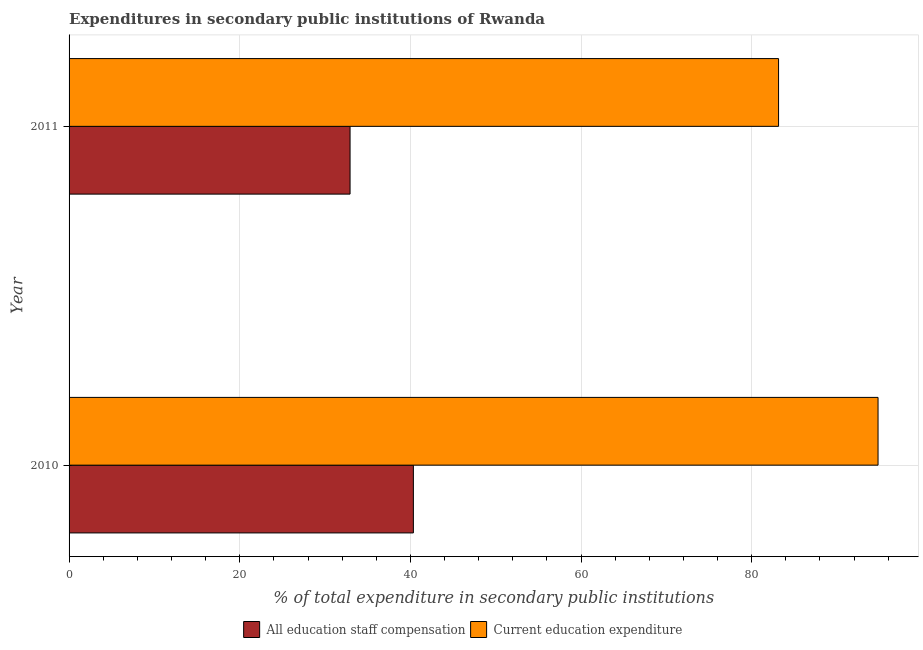How many different coloured bars are there?
Ensure brevity in your answer.  2. Are the number of bars per tick equal to the number of legend labels?
Your response must be concise. Yes. How many bars are there on the 2nd tick from the bottom?
Provide a short and direct response. 2. In how many cases, is the number of bars for a given year not equal to the number of legend labels?
Provide a succinct answer. 0. What is the expenditure in education in 2010?
Your response must be concise. 94.8. Across all years, what is the maximum expenditure in education?
Ensure brevity in your answer.  94.8. Across all years, what is the minimum expenditure in education?
Provide a short and direct response. 83.15. What is the total expenditure in education in the graph?
Keep it short and to the point. 177.95. What is the difference between the expenditure in education in 2010 and that in 2011?
Ensure brevity in your answer.  11.66. What is the difference between the expenditure in education in 2011 and the expenditure in staff compensation in 2010?
Your answer should be compact. 42.8. What is the average expenditure in education per year?
Offer a very short reply. 88.97. In the year 2011, what is the difference between the expenditure in staff compensation and expenditure in education?
Your answer should be very brief. -50.22. What is the ratio of the expenditure in education in 2010 to that in 2011?
Provide a succinct answer. 1.14. Is the difference between the expenditure in education in 2010 and 2011 greater than the difference between the expenditure in staff compensation in 2010 and 2011?
Make the answer very short. Yes. In how many years, is the expenditure in staff compensation greater than the average expenditure in staff compensation taken over all years?
Ensure brevity in your answer.  1. What does the 1st bar from the top in 2011 represents?
Ensure brevity in your answer.  Current education expenditure. What does the 1st bar from the bottom in 2011 represents?
Provide a short and direct response. All education staff compensation. Are all the bars in the graph horizontal?
Keep it short and to the point. Yes. Are the values on the major ticks of X-axis written in scientific E-notation?
Your response must be concise. No. Does the graph contain grids?
Your response must be concise. Yes. How many legend labels are there?
Your response must be concise. 2. How are the legend labels stacked?
Make the answer very short. Horizontal. What is the title of the graph?
Your response must be concise. Expenditures in secondary public institutions of Rwanda. Does "Gasoline" appear as one of the legend labels in the graph?
Provide a succinct answer. No. What is the label or title of the X-axis?
Give a very brief answer. % of total expenditure in secondary public institutions. What is the label or title of the Y-axis?
Your answer should be very brief. Year. What is the % of total expenditure in secondary public institutions in All education staff compensation in 2010?
Provide a short and direct response. 40.35. What is the % of total expenditure in secondary public institutions in Current education expenditure in 2010?
Your response must be concise. 94.8. What is the % of total expenditure in secondary public institutions in All education staff compensation in 2011?
Offer a terse response. 32.93. What is the % of total expenditure in secondary public institutions in Current education expenditure in 2011?
Your answer should be very brief. 83.15. Across all years, what is the maximum % of total expenditure in secondary public institutions of All education staff compensation?
Give a very brief answer. 40.35. Across all years, what is the maximum % of total expenditure in secondary public institutions of Current education expenditure?
Give a very brief answer. 94.8. Across all years, what is the minimum % of total expenditure in secondary public institutions of All education staff compensation?
Offer a terse response. 32.93. Across all years, what is the minimum % of total expenditure in secondary public institutions of Current education expenditure?
Your answer should be compact. 83.15. What is the total % of total expenditure in secondary public institutions of All education staff compensation in the graph?
Your response must be concise. 73.28. What is the total % of total expenditure in secondary public institutions of Current education expenditure in the graph?
Offer a terse response. 177.95. What is the difference between the % of total expenditure in secondary public institutions of All education staff compensation in 2010 and that in 2011?
Provide a short and direct response. 7.42. What is the difference between the % of total expenditure in secondary public institutions of Current education expenditure in 2010 and that in 2011?
Offer a very short reply. 11.66. What is the difference between the % of total expenditure in secondary public institutions of All education staff compensation in 2010 and the % of total expenditure in secondary public institutions of Current education expenditure in 2011?
Your response must be concise. -42.8. What is the average % of total expenditure in secondary public institutions of All education staff compensation per year?
Provide a succinct answer. 36.64. What is the average % of total expenditure in secondary public institutions in Current education expenditure per year?
Ensure brevity in your answer.  88.97. In the year 2010, what is the difference between the % of total expenditure in secondary public institutions of All education staff compensation and % of total expenditure in secondary public institutions of Current education expenditure?
Provide a short and direct response. -54.45. In the year 2011, what is the difference between the % of total expenditure in secondary public institutions of All education staff compensation and % of total expenditure in secondary public institutions of Current education expenditure?
Make the answer very short. -50.22. What is the ratio of the % of total expenditure in secondary public institutions of All education staff compensation in 2010 to that in 2011?
Give a very brief answer. 1.23. What is the ratio of the % of total expenditure in secondary public institutions in Current education expenditure in 2010 to that in 2011?
Ensure brevity in your answer.  1.14. What is the difference between the highest and the second highest % of total expenditure in secondary public institutions of All education staff compensation?
Your answer should be very brief. 7.42. What is the difference between the highest and the second highest % of total expenditure in secondary public institutions in Current education expenditure?
Ensure brevity in your answer.  11.66. What is the difference between the highest and the lowest % of total expenditure in secondary public institutions in All education staff compensation?
Ensure brevity in your answer.  7.42. What is the difference between the highest and the lowest % of total expenditure in secondary public institutions of Current education expenditure?
Make the answer very short. 11.66. 